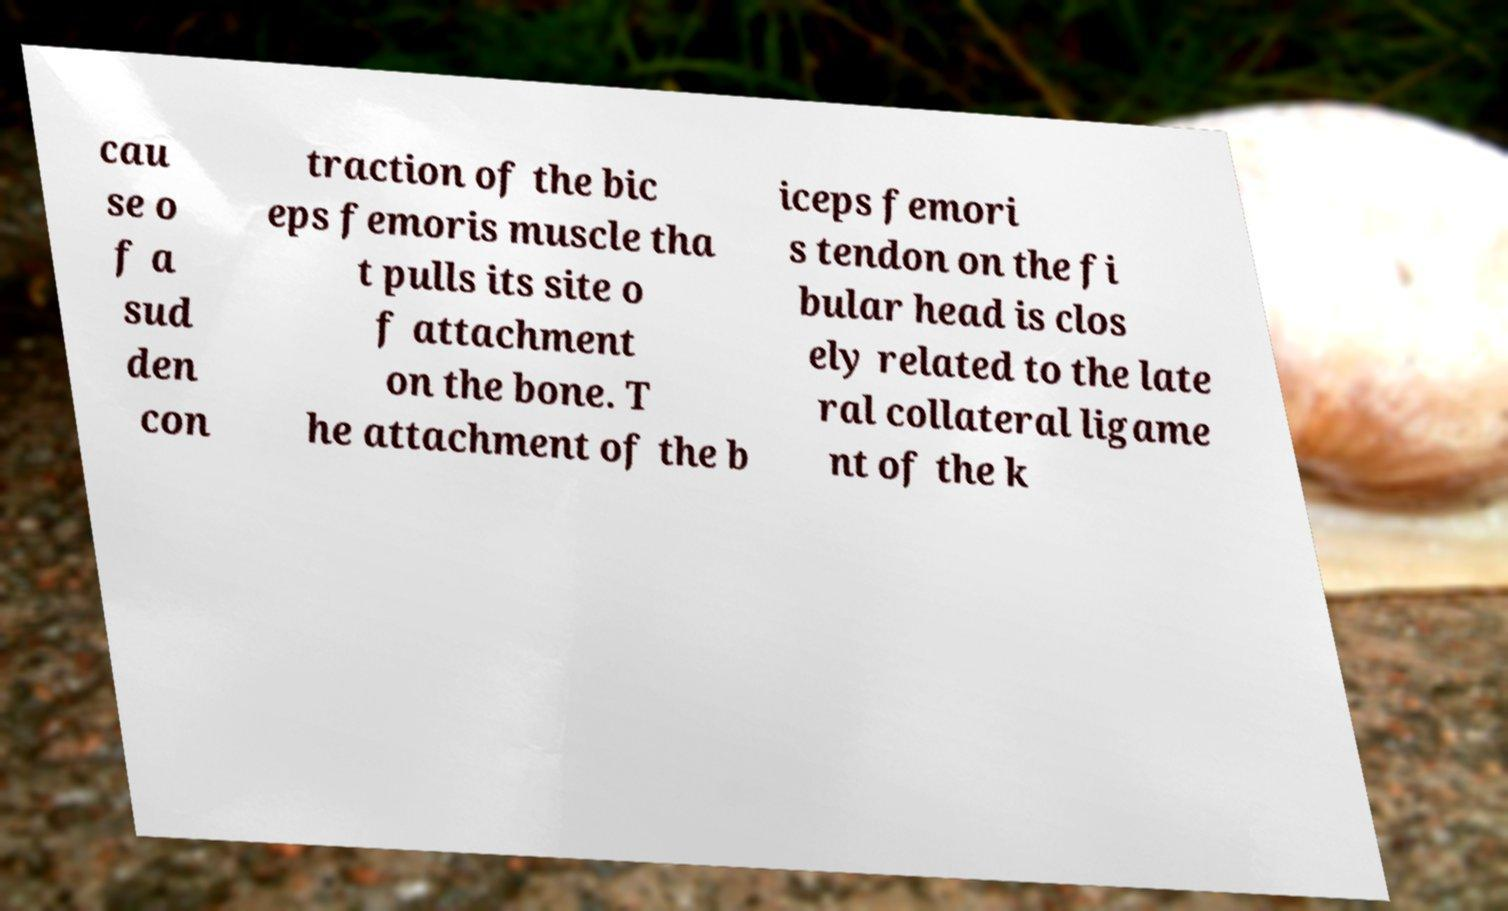Can you accurately transcribe the text from the provided image for me? cau se o f a sud den con traction of the bic eps femoris muscle tha t pulls its site o f attachment on the bone. T he attachment of the b iceps femori s tendon on the fi bular head is clos ely related to the late ral collateral ligame nt of the k 